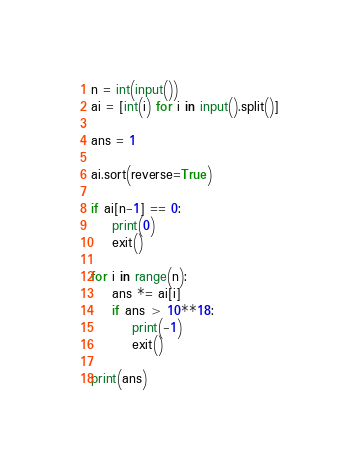Convert code to text. <code><loc_0><loc_0><loc_500><loc_500><_Python_>n = int(input())
ai = [int(i) for i in input().split()]

ans = 1

ai.sort(reverse=True)

if ai[n-1] == 0:
    print(0)
    exit()

for i in range(n):
    ans *= ai[i]
    if ans > 10**18:
        print(-1)
        exit()
    
print(ans)</code> 